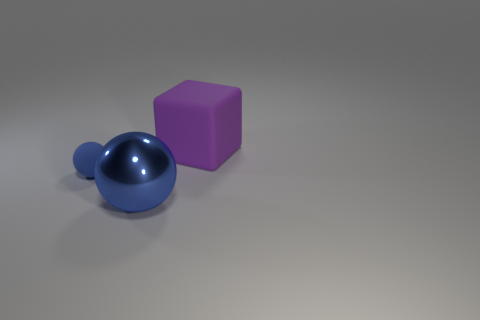There is a rubber thing that is the same size as the shiny sphere; what is its color?
Give a very brief answer. Purple. Are there fewer blue metallic balls that are in front of the big blue object than tiny matte objects on the right side of the small ball?
Provide a short and direct response. No. There is a large purple thing right of the blue ball in front of the small object; what number of large metallic objects are on the right side of it?
Make the answer very short. 0. There is another thing that is the same shape as the big shiny object; what size is it?
Your response must be concise. Small. Is there any other thing that is the same size as the blue matte object?
Provide a short and direct response. No. Is the number of big rubber objects that are on the left side of the small blue object less than the number of big cyan spheres?
Provide a short and direct response. No. Do the blue matte thing and the large matte thing have the same shape?
Your answer should be compact. No. What color is the large metallic thing that is the same shape as the blue matte object?
Provide a succinct answer. Blue. How many metal objects have the same color as the small rubber thing?
Your answer should be very brief. 1. How many objects are tiny blue matte things that are to the left of the large blue shiny object or small rubber balls?
Your answer should be compact. 1. 